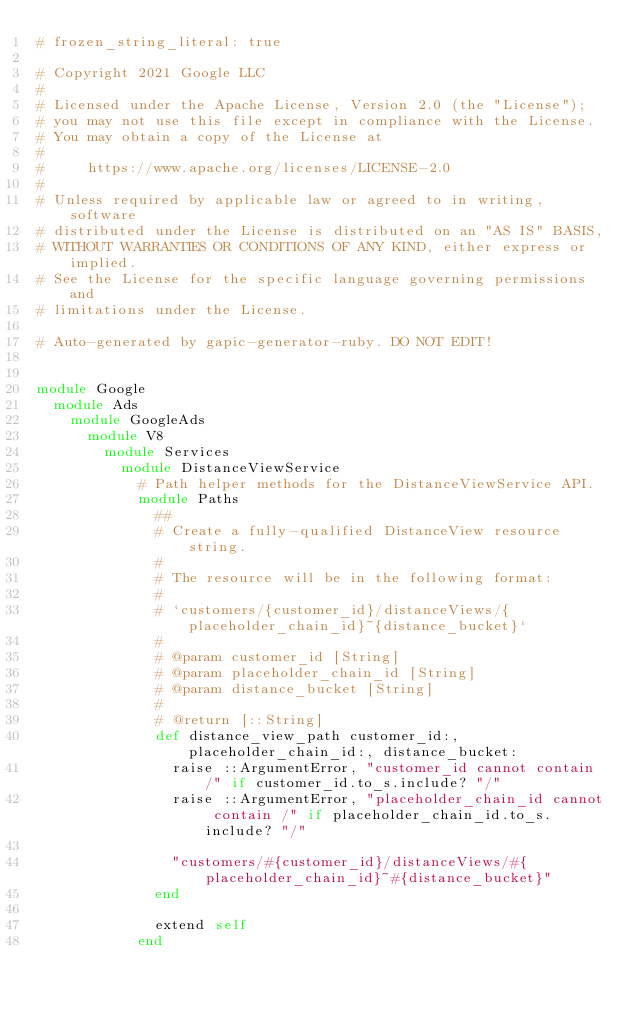<code> <loc_0><loc_0><loc_500><loc_500><_Ruby_># frozen_string_literal: true

# Copyright 2021 Google LLC
#
# Licensed under the Apache License, Version 2.0 (the "License");
# you may not use this file except in compliance with the License.
# You may obtain a copy of the License at
#
#     https://www.apache.org/licenses/LICENSE-2.0
#
# Unless required by applicable law or agreed to in writing, software
# distributed under the License is distributed on an "AS IS" BASIS,
# WITHOUT WARRANTIES OR CONDITIONS OF ANY KIND, either express or implied.
# See the License for the specific language governing permissions and
# limitations under the License.

# Auto-generated by gapic-generator-ruby. DO NOT EDIT!


module Google
  module Ads
    module GoogleAds
      module V8
        module Services
          module DistanceViewService
            # Path helper methods for the DistanceViewService API.
            module Paths
              ##
              # Create a fully-qualified DistanceView resource string.
              #
              # The resource will be in the following format:
              #
              # `customers/{customer_id}/distanceViews/{placeholder_chain_id}~{distance_bucket}`
              #
              # @param customer_id [String]
              # @param placeholder_chain_id [String]
              # @param distance_bucket [String]
              #
              # @return [::String]
              def distance_view_path customer_id:, placeholder_chain_id:, distance_bucket:
                raise ::ArgumentError, "customer_id cannot contain /" if customer_id.to_s.include? "/"
                raise ::ArgumentError, "placeholder_chain_id cannot contain /" if placeholder_chain_id.to_s.include? "/"

                "customers/#{customer_id}/distanceViews/#{placeholder_chain_id}~#{distance_bucket}"
              end

              extend self
            end</code> 